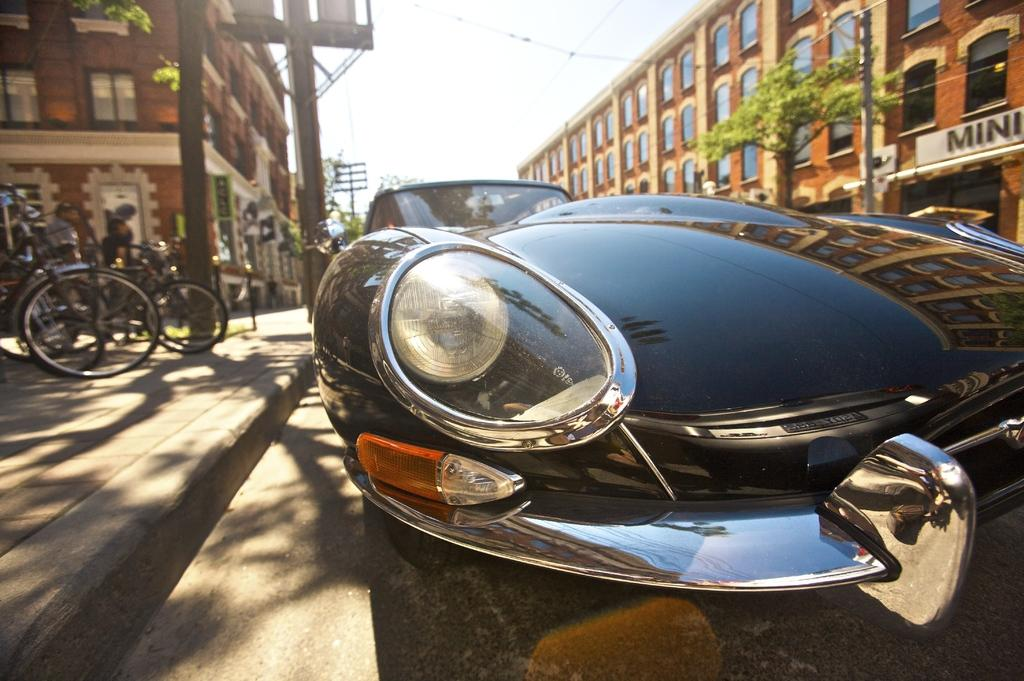What types of objects can be seen in the image? There are vehicles, buildings with windows, poles, and trees in the image. What else can be seen in the image besides the objects mentioned? There are cables and the sky visible in the background of the image. Can you describe the buildings in the image? The buildings have windows. What is the color of the sky in the image? The sky is visible in the background of the image, but the color is not mentioned in the facts. What type of mint is growing near the river in the image? There is no mint or river present in the image. How many windows are there on the window in the image? There is no specific window mentioned in the image, only buildings with windows. 